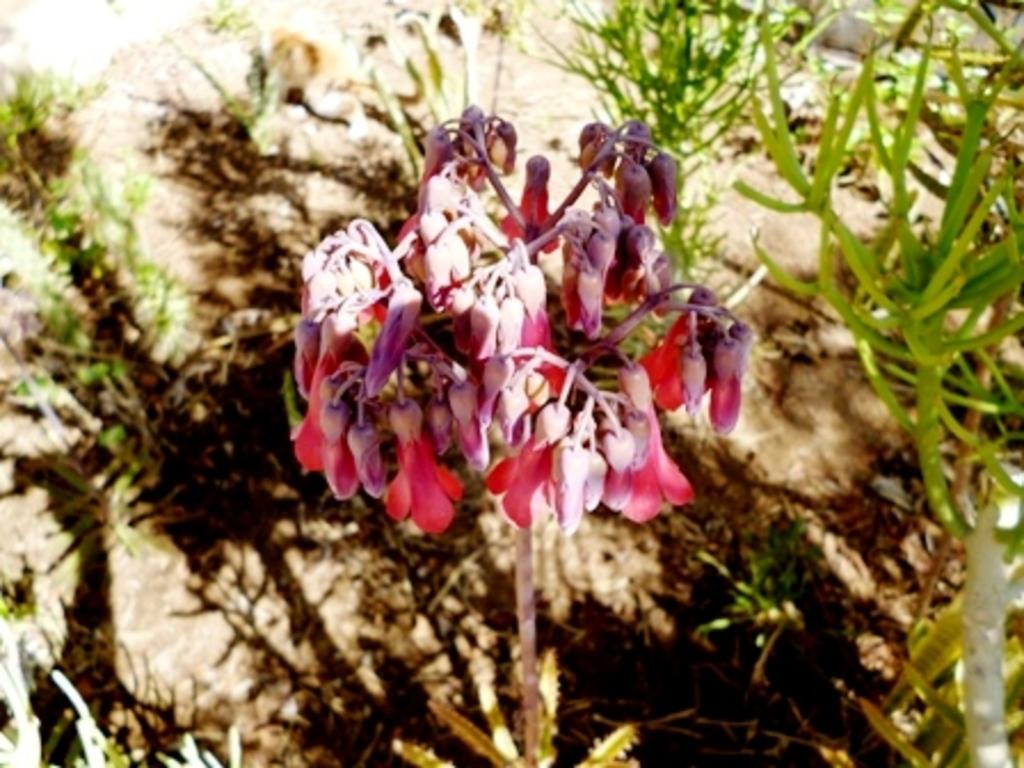What type of flowers can be seen in the image? There are pink flowers in the image. Are there any other plants visible in the image? Yes, there are plants behind the pink flowers in the image. What type of destruction can be seen happening to the flowers in the image? There is no destruction happening to the flowers in the image; they appear to be intact and healthy. 